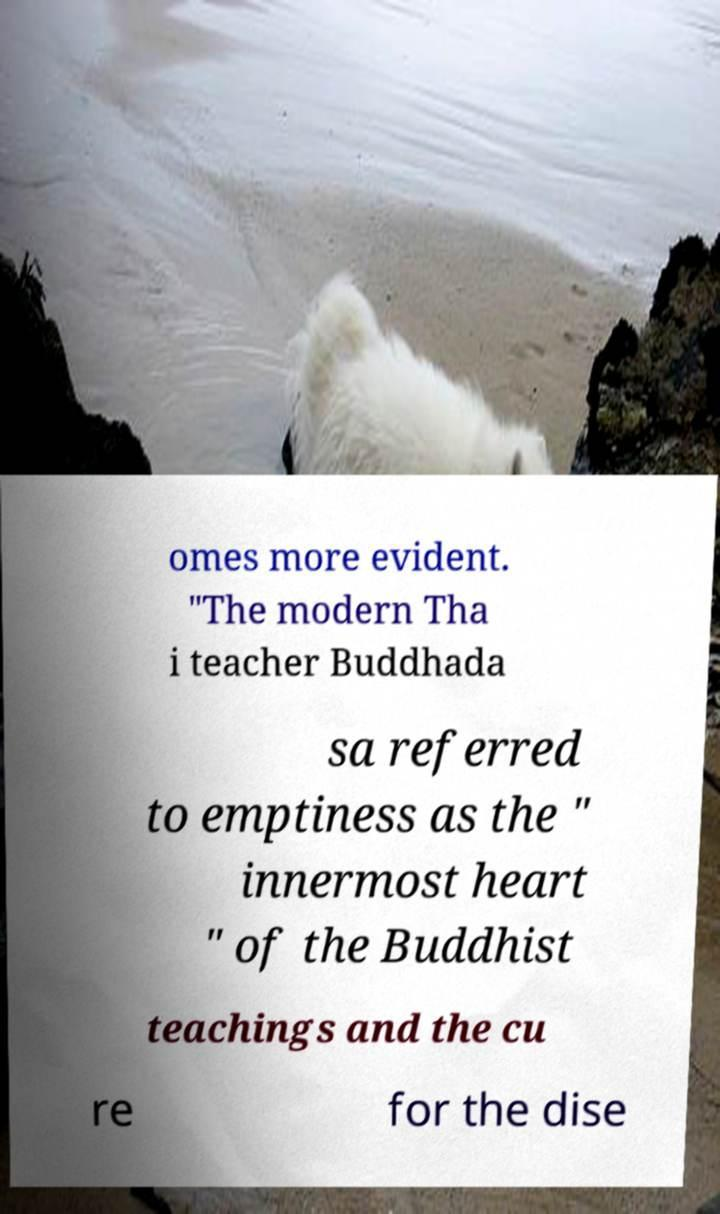I need the written content from this picture converted into text. Can you do that? omes more evident. "The modern Tha i teacher Buddhada sa referred to emptiness as the " innermost heart " of the Buddhist teachings and the cu re for the dise 